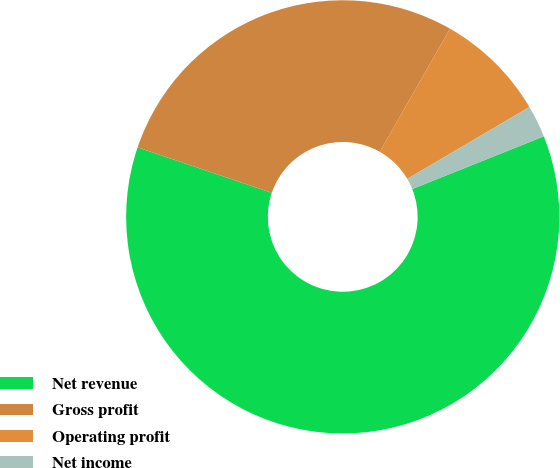Convert chart. <chart><loc_0><loc_0><loc_500><loc_500><pie_chart><fcel>Net revenue<fcel>Gross profit<fcel>Operating profit<fcel>Net income<nl><fcel>61.27%<fcel>28.05%<fcel>8.29%<fcel>2.4%<nl></chart> 